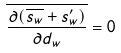<formula> <loc_0><loc_0><loc_500><loc_500>\overline { \frac { \partial ( \overline { s _ { w } } + s _ { w } ^ { \prime } ) } { \partial d _ { w } } } = 0</formula> 